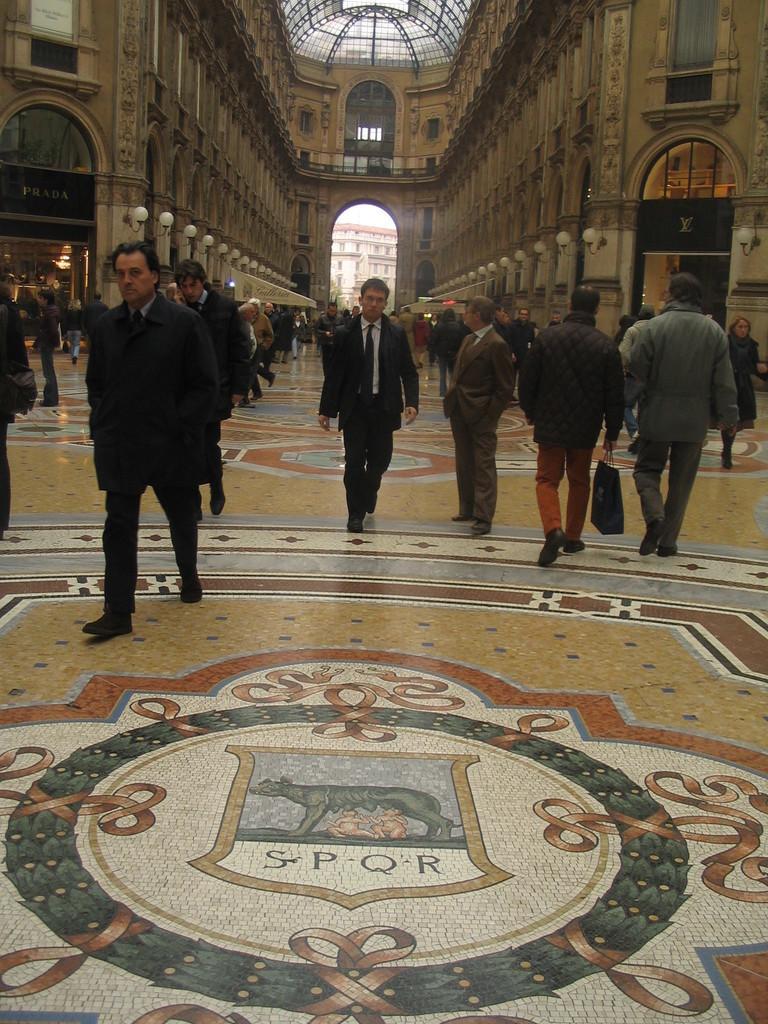Can you describe this image briefly? In this image I can see there is a painting on the floor. In the middle few people are walking, at the back side it is a very big building. 